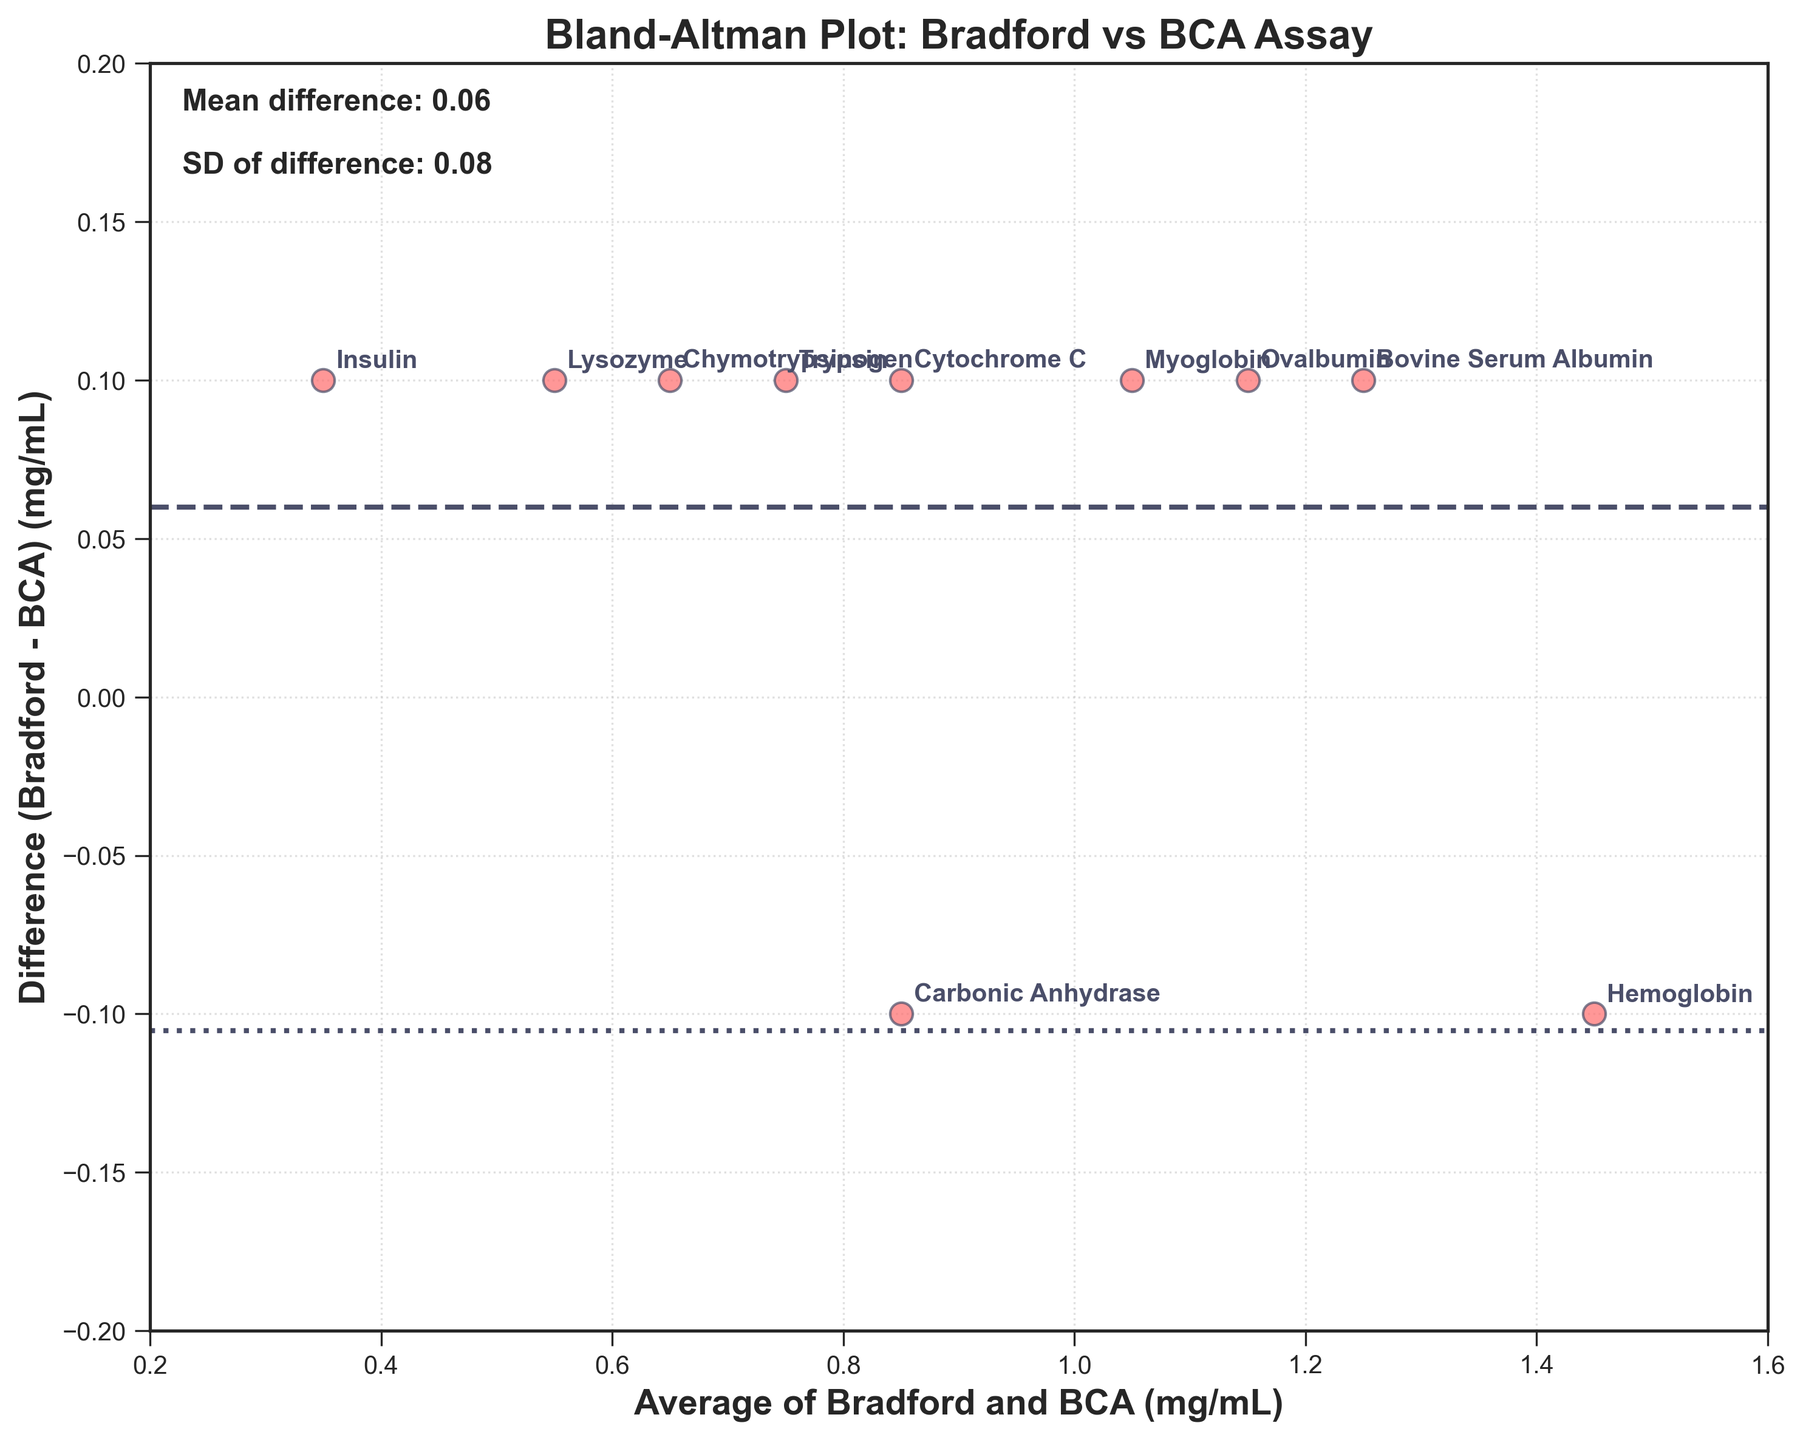what is the title of the plot? The title of a plot is usually displayed at the top. The title of this plot reads "Bland-Altman Plot: Bradford vs BCA Assay".
Answer: Bland-Altman Plot: Bradford vs BCA Assay what is the x-axis label? The x-axis label can be found at the bottom horizontal line of the plot. It reads "Average of Bradford and BCA (mg/mL)".
Answer: Average of Bradford and BCA (mg/mL) what is the y-axis label? The y-axis label is displayed alongside the vertical line of the plot. It reads "Difference (Bradford - BCA) (mg/mL)".
Answer: Difference (Bradford - BCA) (mg/mL) how many data points are there on the plot? The number of data points can be obtained by counting all the individual scatter points on the plot. There are 10 dots corresponding to the methods provided.
Answer: 10 what is the mean difference shown in the plot? The mean difference is typically marked and often shown with a specific annotation or line. It is indicated as 0.06 in this plot through a horizontal dashed line.
Answer: 0.06 what are the upper and lower limits of agreement? The limits of agreement are often represented by dotted lines in a Bland-Altman plot, and these are marked at the mean difference plus and minus 1.96 times the standard deviation. The upper limit is \(0.06 + 1.96 \times 0.09 = 0.2364\), and the lower limit is \(0.06 - 1.96 \times 0.09 = -0.1164\).
Answer: 0.24 and -0.12 which protein displays the highest average concentration? By examining the plot, we observe the x-axis values, where the highest point corresponds to Hemoglobin at 1.45 mg/mL.
Answer: Hemoglobin are there any proteins that have the exact same difference? Inspecting the y-axis values, we see that Bovine Serum Albumin, Cytochrome C, Lysozyme, Insulin, Trypsin, Myoglobin, Ovalbumin, and Chymotrypsinogen all show a difference of 0.1 mg/mL.
Answer: Yes, there are what is the range of average concentrations shown on the x-axis? The x-axis values range from the smallest to the largest value. Based on the plot, these range from approximately 0.35 mg/mL to 1.45 mg/mL.
Answer: 0.35 to 1.45 mg/mL 